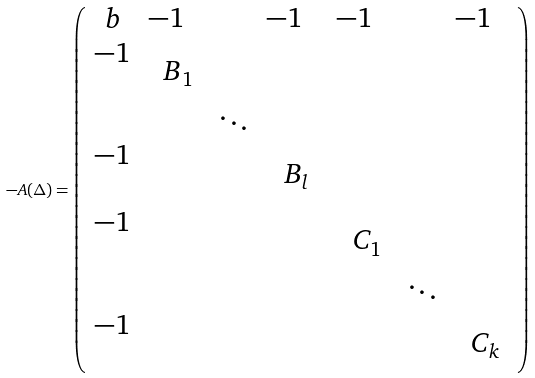<formula> <loc_0><loc_0><loc_500><loc_500>- A ( \Delta ) = \left ( \begin{array} { c c c c c c c } b & \begin{matrix} - 1 & \end{matrix} & & \begin{matrix} - 1 & \end{matrix} & \begin{matrix} - 1 & \end{matrix} & & \begin{matrix} - 1 & \end{matrix} \\ \begin{matrix} - 1 \\ \quad \end{matrix} & \text { $B_{1}$} & & & & & \\ & & \ddots & & & & \\ \begin{matrix} - 1 \\ \quad \end{matrix} & & & \text { $B_{l}$} & & & \\ \begin{matrix} - 1 \\ \quad \end{matrix} & & & & \text { $C_{1}$} & & \\ & & & & & \ddots & \\ \begin{matrix} - 1 \\ \quad \end{matrix} & & & & & & \text { $C_{k}$} \end{array} \right )</formula> 